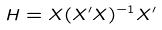Convert formula to latex. <formula><loc_0><loc_0><loc_500><loc_500>H = X ( X ^ { \prime } X ) ^ { - 1 } X ^ { \prime }</formula> 